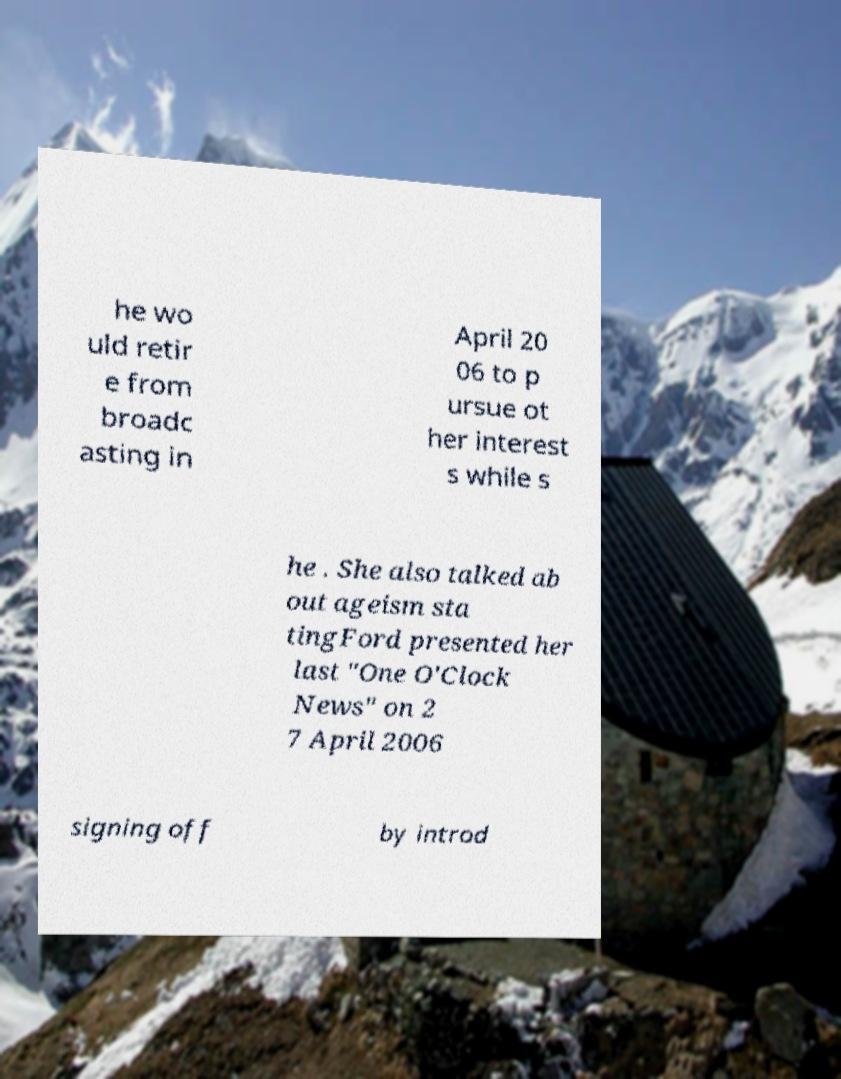Can you accurately transcribe the text from the provided image for me? he wo uld retir e from broadc asting in April 20 06 to p ursue ot her interest s while s he . She also talked ab out ageism sta tingFord presented her last "One O'Clock News" on 2 7 April 2006 signing off by introd 